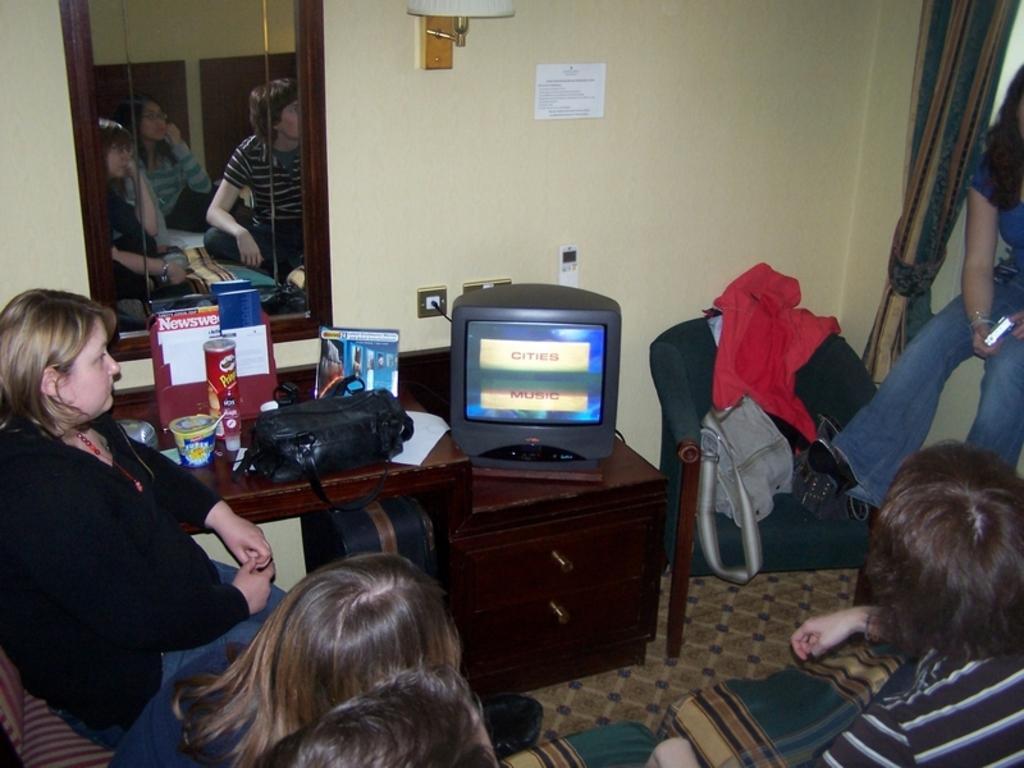Could you give a brief overview of what you see in this image? In this image I can see group of people with different color dresses. To the side of these people I can see the television, black color bag, board, cups and some objects on the brown color table. In the background I can see the mirror, paper and the switch board to the wall. I can see the reflection of three people in the mirror. 